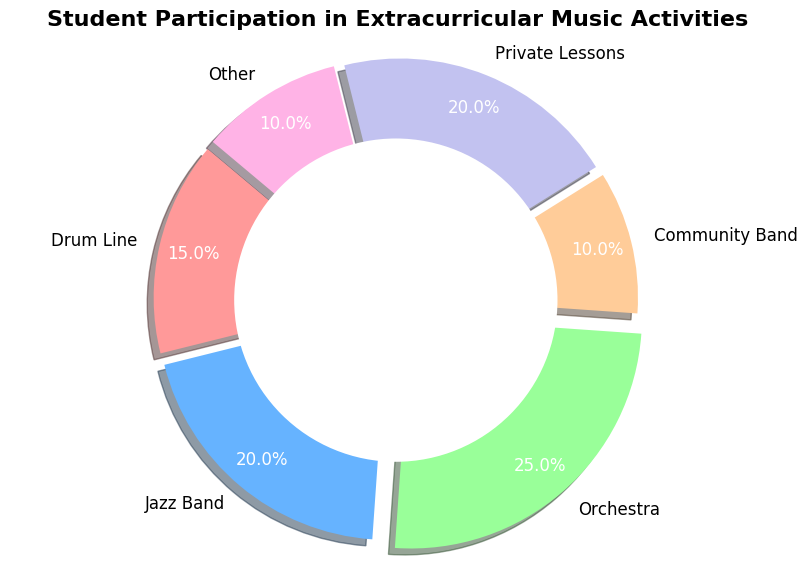What percentage of students participate in Jazz Band and Orchestra combined? To find the total percentage of students participating in both Jazz Band and Orchestra, you add the individual percentages: Jazz Band (20%) and Orchestra (25%). So, 20% + 25% = 45%.
Answer: 45% Which activity has the lowest participation? To determine which activity has the lowest participation, examine the percentages for each activity: Community Band (10%) and Other (10%) have the lowest values. Since they are equal, both have the lowest participation.
Answer: Community Band, Other Are there any activities where the participation is equal? By comparing the given percentages, both Jazz Band (20%) and Private Lessons (20%) have equal participation rates.
Answer: Jazz Band, Private Lessons How much higher is the participation in Orchestra compared to Drum Line? To find the difference in participation, subtract the percentage for Drum Line (15%) from Orchestra (25%): 25% - 15% = 10%.
Answer: 10% What is the total percentage of students participating in activities other than Orchestra? First, calculate the total percentage of all activities: 100%. Then subtract the percentage for Orchestra (25%) from this total: 100% - 25% = 75%.
Answer: 75% Which activity has greater participation: Drum Line or Private Lessons? Comparing the percentages, Drum Line has 15% participation and Private Lessons have 20%. Therefore, Private Lessons has greater participation.
Answer: Private Lessons What is the combined percentage of students participating in Drum Line, Community Band, and Other? To find the combined percentage, add the individual percentages: Drum Line (15%), Community Band (10%), and Other (10%). So, 15% + 10% + 10% = 35%.
Answer: 35% Which activities have a participation rate higher than 10% but less than 25%? By examining the percentages, Jazz Band (20%), Private Lessons (20%), and Drum Line (15%) fall within the range of being higher than 10% but less than 25%.
Answer: Jazz Band, Private Lessons, Drum Line 